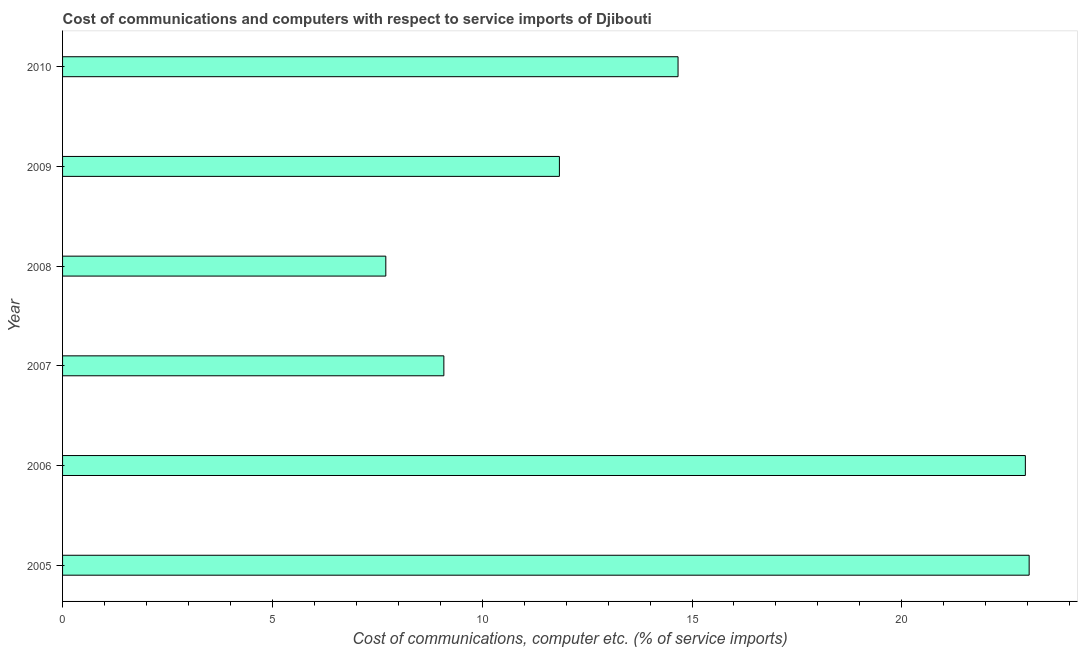Does the graph contain grids?
Provide a short and direct response. No. What is the title of the graph?
Your response must be concise. Cost of communications and computers with respect to service imports of Djibouti. What is the label or title of the X-axis?
Your answer should be very brief. Cost of communications, computer etc. (% of service imports). What is the cost of communications and computer in 2009?
Your answer should be compact. 11.84. Across all years, what is the maximum cost of communications and computer?
Keep it short and to the point. 23.03. Across all years, what is the minimum cost of communications and computer?
Make the answer very short. 7.7. In which year was the cost of communications and computer maximum?
Offer a very short reply. 2005. What is the sum of the cost of communications and computer?
Provide a short and direct response. 89.27. What is the difference between the cost of communications and computer in 2006 and 2007?
Provide a succinct answer. 13.86. What is the average cost of communications and computer per year?
Keep it short and to the point. 14.88. What is the median cost of communications and computer?
Offer a terse response. 13.25. What is the ratio of the cost of communications and computer in 2007 to that in 2008?
Your answer should be compact. 1.18. What is the difference between the highest and the second highest cost of communications and computer?
Your response must be concise. 0.09. Is the sum of the cost of communications and computer in 2005 and 2009 greater than the maximum cost of communications and computer across all years?
Make the answer very short. Yes. What is the difference between the highest and the lowest cost of communications and computer?
Make the answer very short. 15.33. In how many years, is the cost of communications and computer greater than the average cost of communications and computer taken over all years?
Keep it short and to the point. 2. How many bars are there?
Your response must be concise. 6. Are all the bars in the graph horizontal?
Offer a terse response. Yes. What is the Cost of communications, computer etc. (% of service imports) in 2005?
Offer a terse response. 23.03. What is the Cost of communications, computer etc. (% of service imports) of 2006?
Offer a terse response. 22.94. What is the Cost of communications, computer etc. (% of service imports) of 2007?
Make the answer very short. 9.09. What is the Cost of communications, computer etc. (% of service imports) of 2008?
Your response must be concise. 7.7. What is the Cost of communications, computer etc. (% of service imports) in 2009?
Provide a succinct answer. 11.84. What is the Cost of communications, computer etc. (% of service imports) in 2010?
Ensure brevity in your answer.  14.67. What is the difference between the Cost of communications, computer etc. (% of service imports) in 2005 and 2006?
Your response must be concise. 0.09. What is the difference between the Cost of communications, computer etc. (% of service imports) in 2005 and 2007?
Your answer should be compact. 13.95. What is the difference between the Cost of communications, computer etc. (% of service imports) in 2005 and 2008?
Your answer should be very brief. 15.33. What is the difference between the Cost of communications, computer etc. (% of service imports) in 2005 and 2009?
Offer a terse response. 11.19. What is the difference between the Cost of communications, computer etc. (% of service imports) in 2005 and 2010?
Keep it short and to the point. 8.37. What is the difference between the Cost of communications, computer etc. (% of service imports) in 2006 and 2007?
Make the answer very short. 13.86. What is the difference between the Cost of communications, computer etc. (% of service imports) in 2006 and 2008?
Give a very brief answer. 15.24. What is the difference between the Cost of communications, computer etc. (% of service imports) in 2006 and 2009?
Provide a succinct answer. 11.1. What is the difference between the Cost of communications, computer etc. (% of service imports) in 2006 and 2010?
Offer a terse response. 8.28. What is the difference between the Cost of communications, computer etc. (% of service imports) in 2007 and 2008?
Offer a terse response. 1.38. What is the difference between the Cost of communications, computer etc. (% of service imports) in 2007 and 2009?
Your answer should be very brief. -2.75. What is the difference between the Cost of communications, computer etc. (% of service imports) in 2007 and 2010?
Offer a very short reply. -5.58. What is the difference between the Cost of communications, computer etc. (% of service imports) in 2008 and 2009?
Offer a very short reply. -4.14. What is the difference between the Cost of communications, computer etc. (% of service imports) in 2008 and 2010?
Keep it short and to the point. -6.96. What is the difference between the Cost of communications, computer etc. (% of service imports) in 2009 and 2010?
Offer a terse response. -2.83. What is the ratio of the Cost of communications, computer etc. (% of service imports) in 2005 to that in 2006?
Your answer should be very brief. 1. What is the ratio of the Cost of communications, computer etc. (% of service imports) in 2005 to that in 2007?
Provide a short and direct response. 2.54. What is the ratio of the Cost of communications, computer etc. (% of service imports) in 2005 to that in 2008?
Your response must be concise. 2.99. What is the ratio of the Cost of communications, computer etc. (% of service imports) in 2005 to that in 2009?
Give a very brief answer. 1.95. What is the ratio of the Cost of communications, computer etc. (% of service imports) in 2005 to that in 2010?
Give a very brief answer. 1.57. What is the ratio of the Cost of communications, computer etc. (% of service imports) in 2006 to that in 2007?
Ensure brevity in your answer.  2.52. What is the ratio of the Cost of communications, computer etc. (% of service imports) in 2006 to that in 2008?
Ensure brevity in your answer.  2.98. What is the ratio of the Cost of communications, computer etc. (% of service imports) in 2006 to that in 2009?
Keep it short and to the point. 1.94. What is the ratio of the Cost of communications, computer etc. (% of service imports) in 2006 to that in 2010?
Offer a terse response. 1.56. What is the ratio of the Cost of communications, computer etc. (% of service imports) in 2007 to that in 2008?
Your response must be concise. 1.18. What is the ratio of the Cost of communications, computer etc. (% of service imports) in 2007 to that in 2009?
Provide a succinct answer. 0.77. What is the ratio of the Cost of communications, computer etc. (% of service imports) in 2007 to that in 2010?
Your answer should be compact. 0.62. What is the ratio of the Cost of communications, computer etc. (% of service imports) in 2008 to that in 2009?
Keep it short and to the point. 0.65. What is the ratio of the Cost of communications, computer etc. (% of service imports) in 2008 to that in 2010?
Offer a very short reply. 0.53. What is the ratio of the Cost of communications, computer etc. (% of service imports) in 2009 to that in 2010?
Keep it short and to the point. 0.81. 